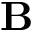Convert formula to latex. <formula><loc_0><loc_0><loc_500><loc_500>B</formula> 